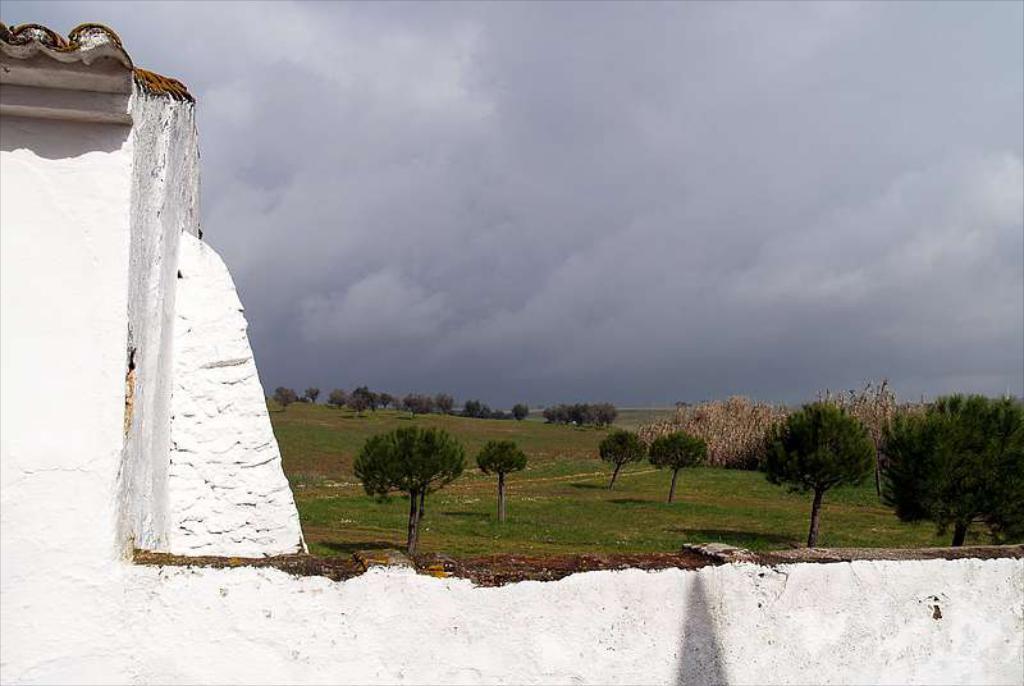In one or two sentences, can you explain what this image depicts? In this image there are trees and sky. At the bottom there is a wall. 